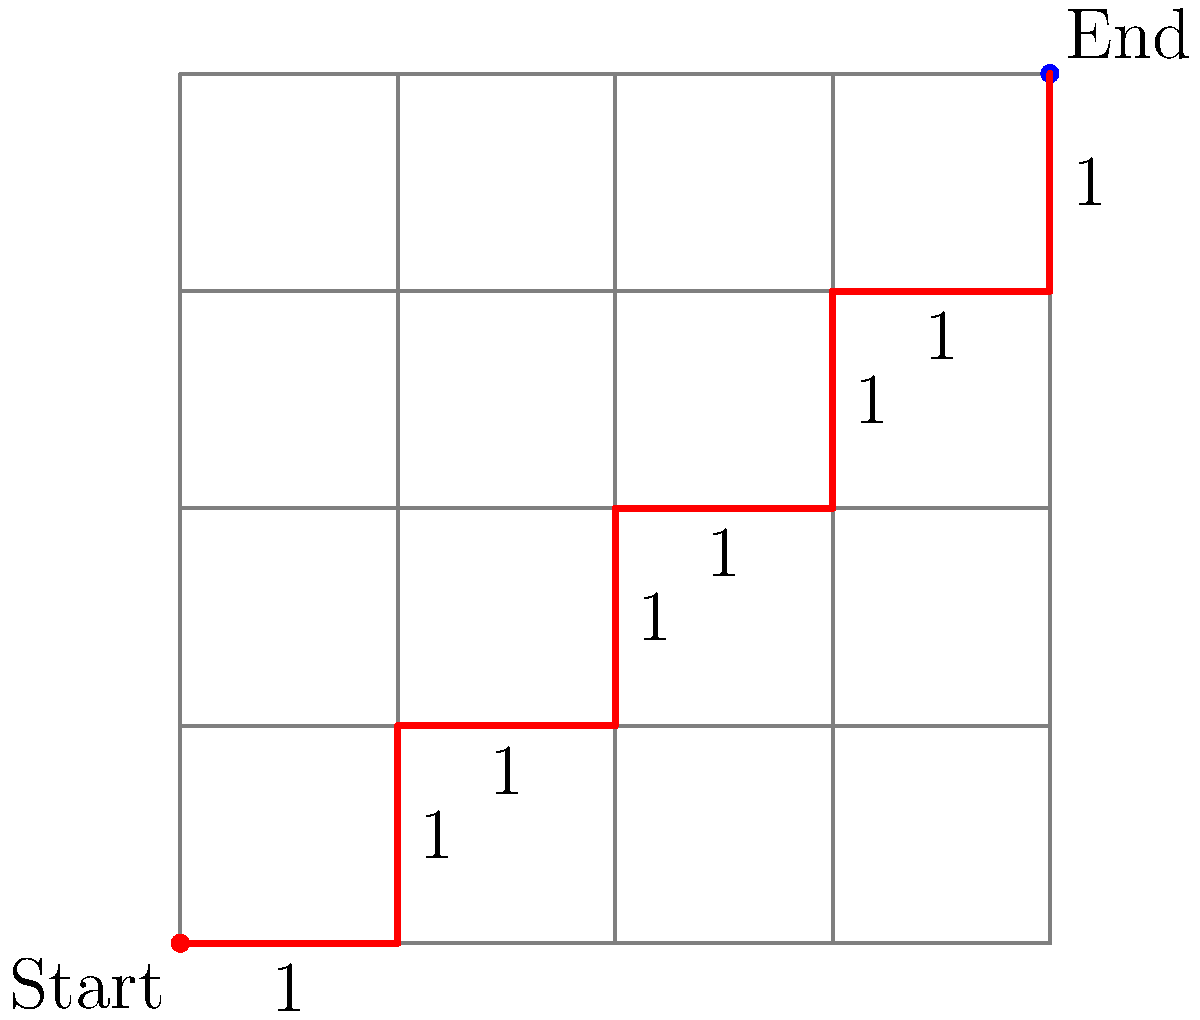In the city grid shown above, each block represents a distance of 1 unit. As a police officer, you need to determine the optimal patrol route from the start point (bottom-left corner) to the end point (top-right corner). What is the total distance of the shortest path, and how many different shortest paths are possible? To solve this problem, we'll use the concepts of vector addition and combinatorics:

1. Shortest distance:
   - The grid is 4x4, so we need to move 4 units right and 4 units up.
   - Total distance = 4 + 4 = 8 units

2. Number of shortest paths:
   - We need to make 8 moves in total: 4 right (R) and 4 up (U).
   - The question is: how many ways can we arrange 4 R's and 4 U's?
   - This is a combination problem, calculated as:
     $$\binom{8}{4} = \frac{8!}{4!(8-4)!} = \frac{8!}{4!4!}$$
   - Calculating:
     $$\frac{8 * 7 * 6 * 5}{4 * 3 * 2 * 1} = \frac{1680}{24} = 70$$

Therefore, there are 70 different shortest paths, each with a distance of 8 units.
Answer: 8 units; 70 paths 